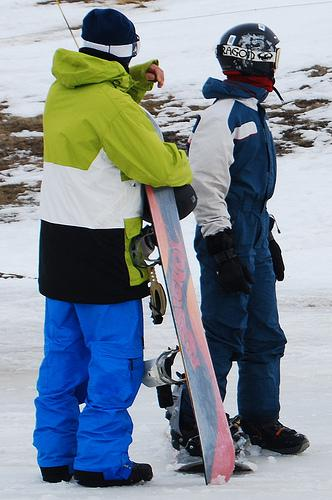Question: who is holding the board?
Choices:
A. The individual with the green jacket.
B. The carpenter.
C. The carpenter's helper.
D. His friend.
Answer with the letter. Answer: A Question: why are the people wearing coats?
Choices:
A. To stay warm.
B. They are flying to the north.
C. Going skiing.
D. Due to the cold weather.
Answer with the letter. Answer: D Question: how many people are wearing blue plants?
Choices:
A. 3.
B. 4.
C. 2.
D. 5.
Answer with the letter. Answer: C Question: how many black shoes are there?
Choices:
A. 6.
B. 8.
C. 4.
D. 2.
Answer with the letter. Answer: C Question: where are the gloves?
Choices:
A. On the boy's hands.
B. In the player's pocket.
C. In the store.
D. In the coat pocket.
Answer with the letter. Answer: A 